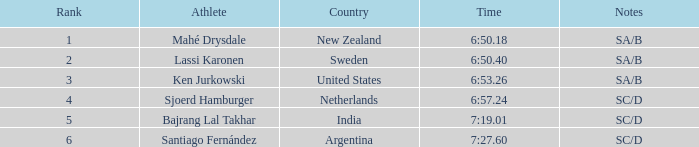What is mentioned in the notes regarding the sportsman, lassi karonen? SA/B. 